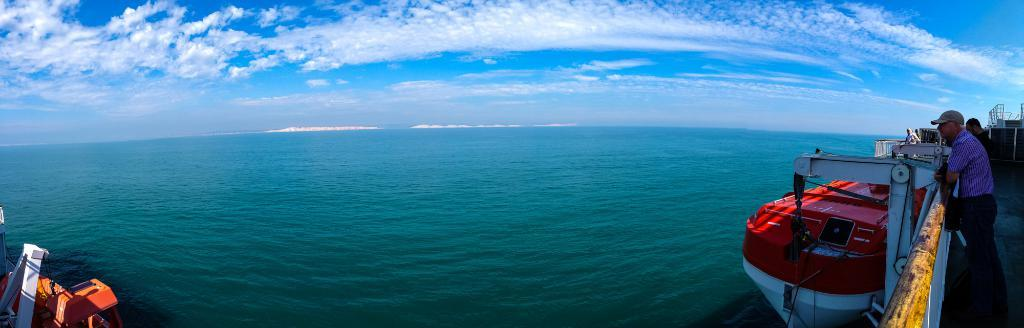What are the people in the image standing on? The people in the image are standing on a ship. Where is the ship located? The ship is on the ocean. What can be seen in the sky in the image? Clouds are present in the sky. Can you describe the sky's condition in the image? The sky is visible in the image, and clouds are present. What type of sign can be seen on the front of the ship in the image? There is no sign visible on the front of the ship in the image. How many balls are being juggled by the people on the ship in the image? There are no balls or juggling activities depicted in the image. 